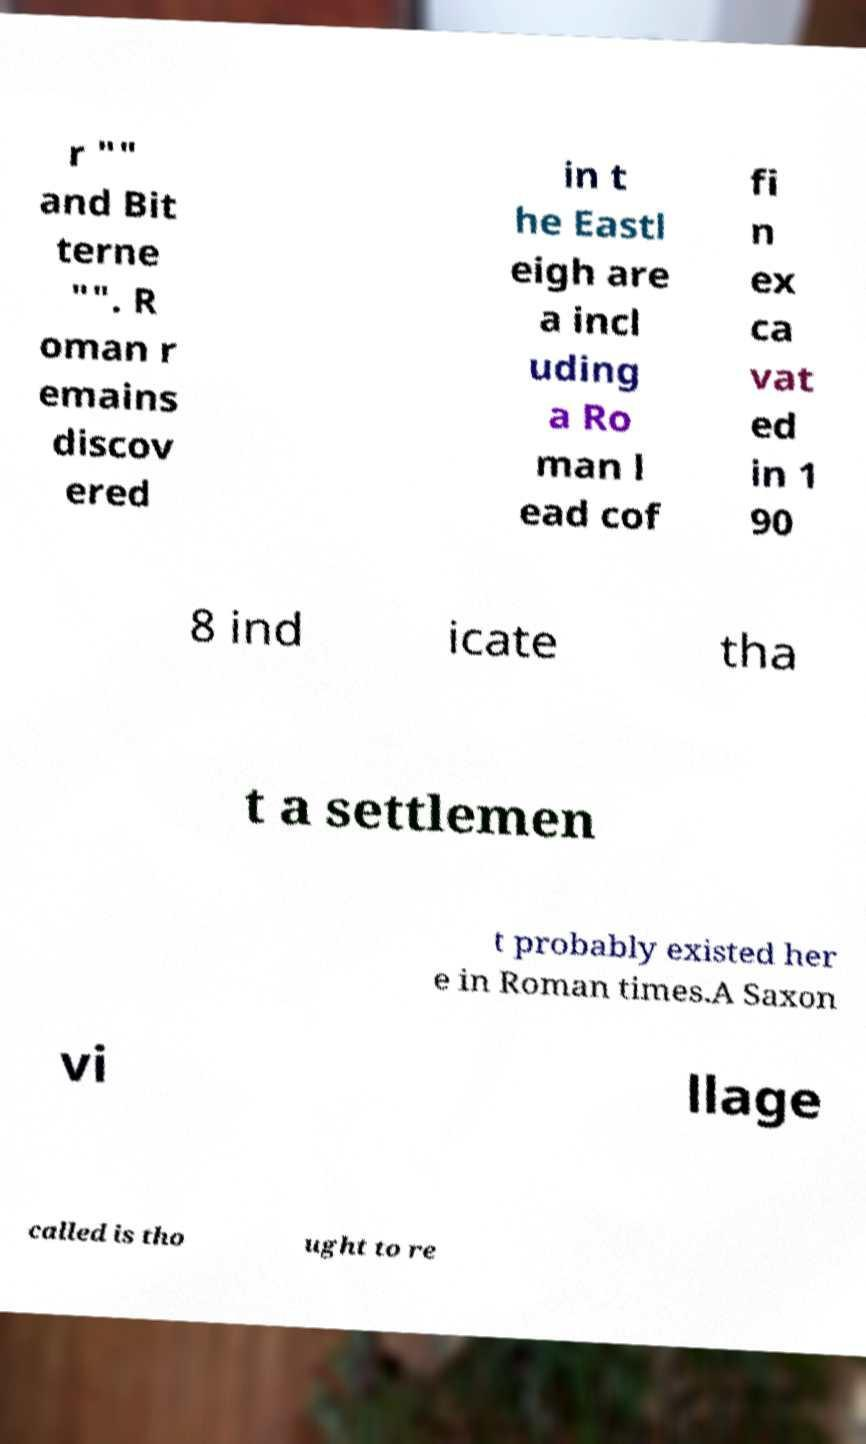What messages or text are displayed in this image? I need them in a readable, typed format. r "" and Bit terne "". R oman r emains discov ered in t he Eastl eigh are a incl uding a Ro man l ead cof fi n ex ca vat ed in 1 90 8 ind icate tha t a settlemen t probably existed her e in Roman times.A Saxon vi llage called is tho ught to re 